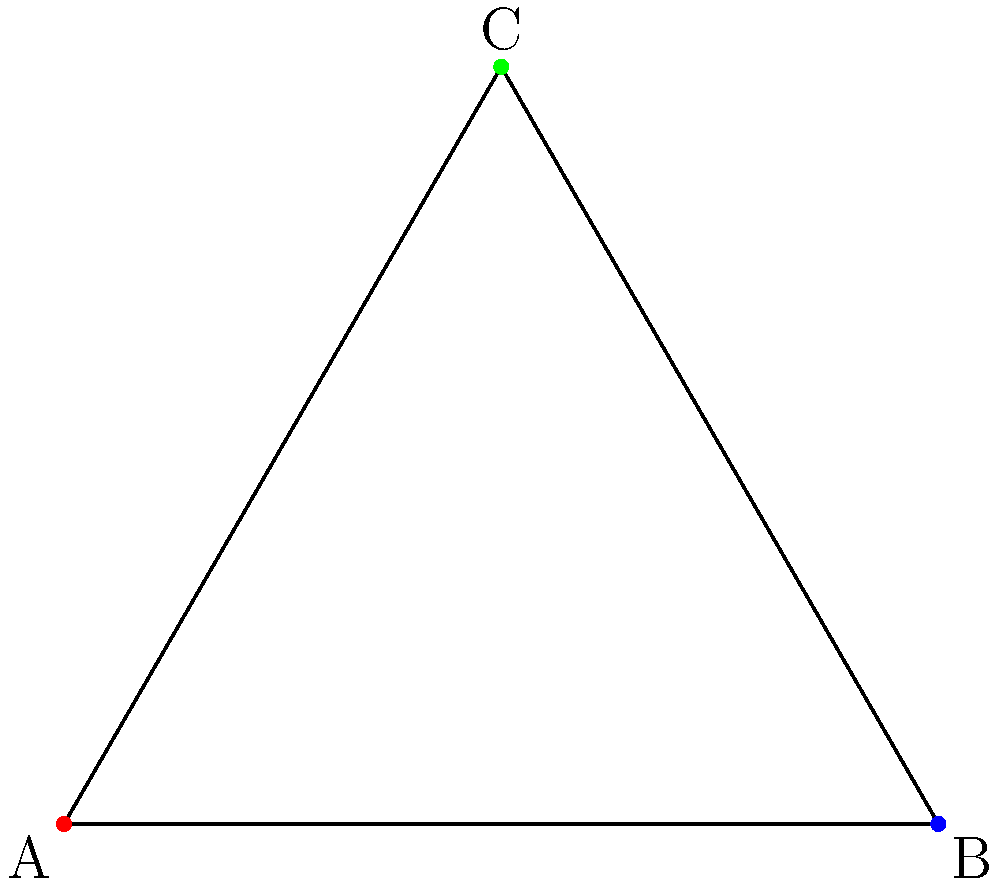In the context of group theory applied to archival systems, consider the equilateral triangle ABC with centroid D as shown. If the dihedral group $D_3$ acts on this triangle, how many distinct images of point D will be produced under all possible group actions? To solve this problem, let's follow these steps:

1. Understand the dihedral group $D_3$:
   - $D_3$ is the symmetry group of an equilateral triangle.
   - It consists of 6 elements: 3 rotations and 3 reflections.

2. Analyze the symmetries of the triangle:
   - Rotations: 0°, 120°, and 240° around the centroid.
   - Reflections: across the three medians.

3. Consider the position of point D (the centroid):
   - D is located at the intersection of the three medians.
   - D is equidistant from all three vertices.

4. Examine the effect of group actions on D:
   - Rotations: All rotations leave D fixed as it's the center of rotation.
   - Reflections: All reflections leave D fixed as it lies on all lines of symmetry.

5. Count the distinct images of D:
   - Under all 6 transformations of $D_3$, point D remains in the same position.
   - Therefore, there is only 1 distinct image of D.

In the context of archival systems, this invariance of the centroid under group actions could represent the stability and centrality of core archival principles or central data structures that remain unchanged under various organizational or operational transformations.
Answer: 1 